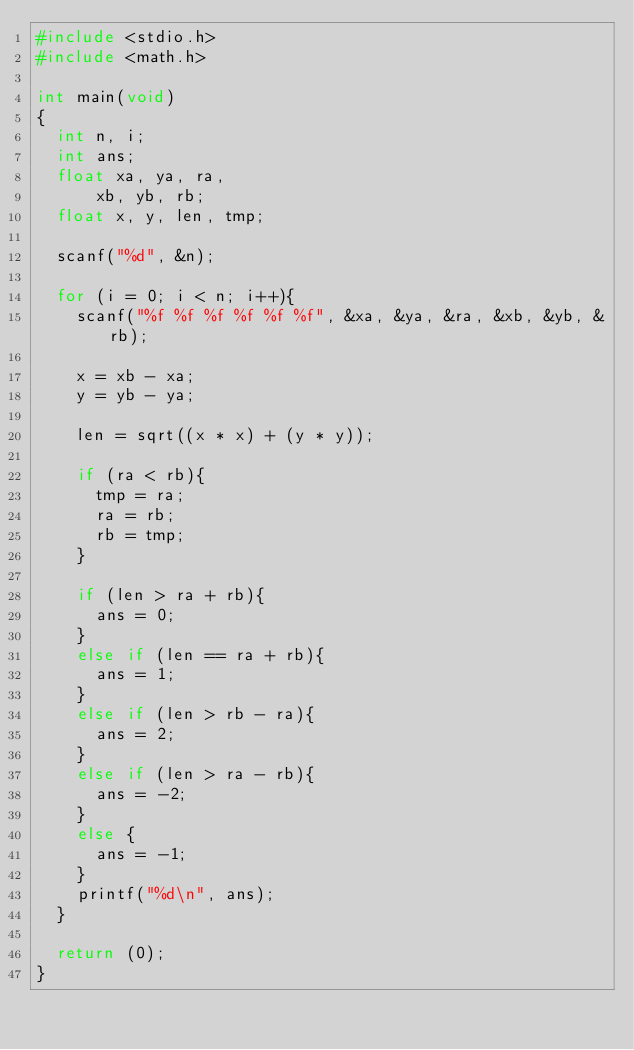Convert code to text. <code><loc_0><loc_0><loc_500><loc_500><_C_>#include <stdio.h>
#include <math.h>

int main(void)
{
	int n, i;
	int ans;
	float xa, ya, ra,
		  xb, yb, rb;
	float x, y, len, tmp;
	
	scanf("%d", &n);
	
	for (i = 0; i < n; i++){
		scanf("%f %f %f %f %f %f", &xa, &ya, &ra, &xb, &yb, &rb);
		
		x = xb - xa;
		y = yb - ya;
		
		len = sqrt((x * x) + (y * y));
		
		if (ra < rb){
			tmp = ra;
			ra = rb;
			rb = tmp;
		}
		
		if (len > ra + rb){
			ans = 0;
		}
		else if (len == ra + rb){
			ans = 1;
		}
		else if (len > rb - ra){
			ans = 2;
		}
		else if (len > ra - rb){
			ans = -2;
		}
		else {
			ans = -1;
		}
		printf("%d\n", ans);
	}
	
	return (0);
}</code> 